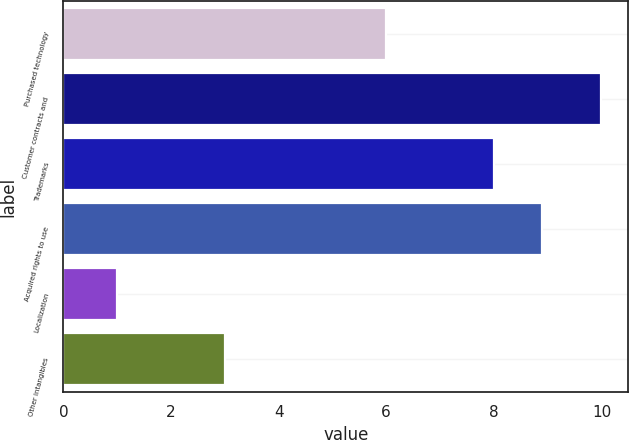<chart> <loc_0><loc_0><loc_500><loc_500><bar_chart><fcel>Purchased technology<fcel>Customer contracts and<fcel>Trademarks<fcel>Acquired rights to use<fcel>Localization<fcel>Other intangibles<nl><fcel>6<fcel>10<fcel>8<fcel>8.9<fcel>1<fcel>3<nl></chart> 